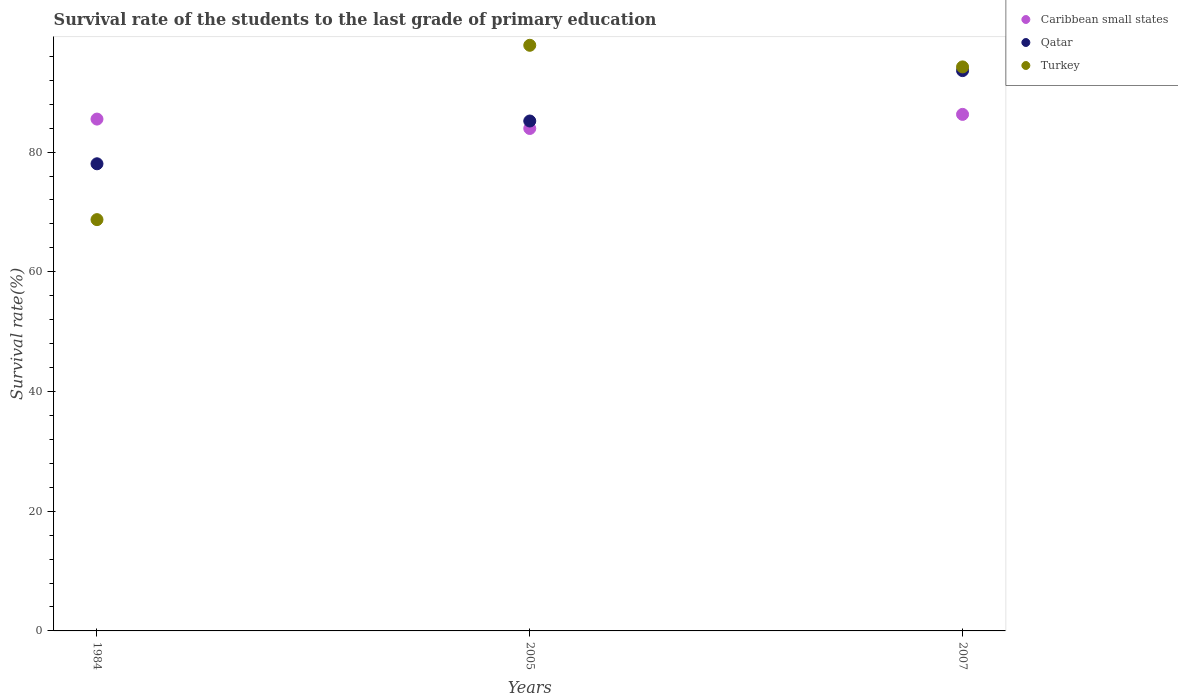Is the number of dotlines equal to the number of legend labels?
Provide a short and direct response. Yes. What is the survival rate of the students in Caribbean small states in 1984?
Your response must be concise. 85.51. Across all years, what is the maximum survival rate of the students in Caribbean small states?
Make the answer very short. 86.3. Across all years, what is the minimum survival rate of the students in Qatar?
Provide a short and direct response. 78.05. In which year was the survival rate of the students in Caribbean small states maximum?
Offer a very short reply. 2007. In which year was the survival rate of the students in Turkey minimum?
Offer a terse response. 1984. What is the total survival rate of the students in Turkey in the graph?
Offer a terse response. 260.79. What is the difference between the survival rate of the students in Caribbean small states in 1984 and that in 2007?
Offer a terse response. -0.79. What is the difference between the survival rate of the students in Turkey in 2005 and the survival rate of the students in Caribbean small states in 2007?
Provide a short and direct response. 11.54. What is the average survival rate of the students in Caribbean small states per year?
Give a very brief answer. 85.25. In the year 2007, what is the difference between the survival rate of the students in Caribbean small states and survival rate of the students in Turkey?
Provide a short and direct response. -7.93. In how many years, is the survival rate of the students in Caribbean small states greater than 36 %?
Your answer should be compact. 3. What is the ratio of the survival rate of the students in Caribbean small states in 1984 to that in 2007?
Your answer should be compact. 0.99. Is the survival rate of the students in Qatar in 2005 less than that in 2007?
Offer a terse response. Yes. What is the difference between the highest and the second highest survival rate of the students in Caribbean small states?
Provide a succinct answer. 0.79. What is the difference between the highest and the lowest survival rate of the students in Turkey?
Offer a terse response. 29.13. Is the sum of the survival rate of the students in Turkey in 1984 and 2005 greater than the maximum survival rate of the students in Qatar across all years?
Offer a terse response. Yes. Is it the case that in every year, the sum of the survival rate of the students in Qatar and survival rate of the students in Caribbean small states  is greater than the survival rate of the students in Turkey?
Give a very brief answer. Yes. Does the survival rate of the students in Caribbean small states monotonically increase over the years?
Provide a short and direct response. No. Is the survival rate of the students in Caribbean small states strictly greater than the survival rate of the students in Turkey over the years?
Offer a terse response. No. Is the survival rate of the students in Qatar strictly less than the survival rate of the students in Turkey over the years?
Your response must be concise. No. How many dotlines are there?
Keep it short and to the point. 3. What is the difference between two consecutive major ticks on the Y-axis?
Provide a succinct answer. 20. Are the values on the major ticks of Y-axis written in scientific E-notation?
Your answer should be compact. No. What is the title of the graph?
Give a very brief answer. Survival rate of the students to the last grade of primary education. What is the label or title of the X-axis?
Your answer should be compact. Years. What is the label or title of the Y-axis?
Provide a succinct answer. Survival rate(%). What is the Survival rate(%) of Caribbean small states in 1984?
Give a very brief answer. 85.51. What is the Survival rate(%) in Qatar in 1984?
Ensure brevity in your answer.  78.05. What is the Survival rate(%) of Turkey in 1984?
Make the answer very short. 68.72. What is the Survival rate(%) of Caribbean small states in 2005?
Ensure brevity in your answer.  83.94. What is the Survival rate(%) in Qatar in 2005?
Your response must be concise. 85.19. What is the Survival rate(%) of Turkey in 2005?
Your answer should be compact. 97.84. What is the Survival rate(%) of Caribbean small states in 2007?
Give a very brief answer. 86.3. What is the Survival rate(%) in Qatar in 2007?
Provide a short and direct response. 93.61. What is the Survival rate(%) of Turkey in 2007?
Provide a short and direct response. 94.23. Across all years, what is the maximum Survival rate(%) in Caribbean small states?
Your answer should be compact. 86.3. Across all years, what is the maximum Survival rate(%) in Qatar?
Make the answer very short. 93.61. Across all years, what is the maximum Survival rate(%) in Turkey?
Give a very brief answer. 97.84. Across all years, what is the minimum Survival rate(%) in Caribbean small states?
Provide a succinct answer. 83.94. Across all years, what is the minimum Survival rate(%) in Qatar?
Your answer should be very brief. 78.05. Across all years, what is the minimum Survival rate(%) in Turkey?
Make the answer very short. 68.72. What is the total Survival rate(%) of Caribbean small states in the graph?
Provide a short and direct response. 255.76. What is the total Survival rate(%) in Qatar in the graph?
Offer a terse response. 256.85. What is the total Survival rate(%) in Turkey in the graph?
Your response must be concise. 260.79. What is the difference between the Survival rate(%) in Caribbean small states in 1984 and that in 2005?
Your answer should be compact. 1.57. What is the difference between the Survival rate(%) in Qatar in 1984 and that in 2005?
Your answer should be very brief. -7.15. What is the difference between the Survival rate(%) of Turkey in 1984 and that in 2005?
Make the answer very short. -29.13. What is the difference between the Survival rate(%) in Caribbean small states in 1984 and that in 2007?
Keep it short and to the point. -0.79. What is the difference between the Survival rate(%) of Qatar in 1984 and that in 2007?
Provide a succinct answer. -15.57. What is the difference between the Survival rate(%) in Turkey in 1984 and that in 2007?
Give a very brief answer. -25.52. What is the difference between the Survival rate(%) of Caribbean small states in 2005 and that in 2007?
Your answer should be compact. -2.36. What is the difference between the Survival rate(%) in Qatar in 2005 and that in 2007?
Offer a very short reply. -8.42. What is the difference between the Survival rate(%) of Turkey in 2005 and that in 2007?
Give a very brief answer. 3.61. What is the difference between the Survival rate(%) in Caribbean small states in 1984 and the Survival rate(%) in Qatar in 2005?
Offer a terse response. 0.32. What is the difference between the Survival rate(%) in Caribbean small states in 1984 and the Survival rate(%) in Turkey in 2005?
Provide a succinct answer. -12.33. What is the difference between the Survival rate(%) in Qatar in 1984 and the Survival rate(%) in Turkey in 2005?
Keep it short and to the point. -19.8. What is the difference between the Survival rate(%) in Caribbean small states in 1984 and the Survival rate(%) in Qatar in 2007?
Make the answer very short. -8.1. What is the difference between the Survival rate(%) of Caribbean small states in 1984 and the Survival rate(%) of Turkey in 2007?
Give a very brief answer. -8.72. What is the difference between the Survival rate(%) in Qatar in 1984 and the Survival rate(%) in Turkey in 2007?
Your response must be concise. -16.19. What is the difference between the Survival rate(%) of Caribbean small states in 2005 and the Survival rate(%) of Qatar in 2007?
Ensure brevity in your answer.  -9.67. What is the difference between the Survival rate(%) of Caribbean small states in 2005 and the Survival rate(%) of Turkey in 2007?
Ensure brevity in your answer.  -10.29. What is the difference between the Survival rate(%) of Qatar in 2005 and the Survival rate(%) of Turkey in 2007?
Make the answer very short. -9.04. What is the average Survival rate(%) of Caribbean small states per year?
Your answer should be very brief. 85.25. What is the average Survival rate(%) in Qatar per year?
Offer a terse response. 85.62. What is the average Survival rate(%) in Turkey per year?
Your answer should be very brief. 86.93. In the year 1984, what is the difference between the Survival rate(%) of Caribbean small states and Survival rate(%) of Qatar?
Your answer should be compact. 7.47. In the year 1984, what is the difference between the Survival rate(%) of Caribbean small states and Survival rate(%) of Turkey?
Your response must be concise. 16.8. In the year 1984, what is the difference between the Survival rate(%) of Qatar and Survival rate(%) of Turkey?
Make the answer very short. 9.33. In the year 2005, what is the difference between the Survival rate(%) of Caribbean small states and Survival rate(%) of Qatar?
Your response must be concise. -1.25. In the year 2005, what is the difference between the Survival rate(%) in Caribbean small states and Survival rate(%) in Turkey?
Your answer should be compact. -13.9. In the year 2005, what is the difference between the Survival rate(%) in Qatar and Survival rate(%) in Turkey?
Provide a succinct answer. -12.65. In the year 2007, what is the difference between the Survival rate(%) of Caribbean small states and Survival rate(%) of Qatar?
Make the answer very short. -7.31. In the year 2007, what is the difference between the Survival rate(%) of Caribbean small states and Survival rate(%) of Turkey?
Your answer should be very brief. -7.93. In the year 2007, what is the difference between the Survival rate(%) of Qatar and Survival rate(%) of Turkey?
Your answer should be compact. -0.62. What is the ratio of the Survival rate(%) in Caribbean small states in 1984 to that in 2005?
Offer a very short reply. 1.02. What is the ratio of the Survival rate(%) of Qatar in 1984 to that in 2005?
Make the answer very short. 0.92. What is the ratio of the Survival rate(%) in Turkey in 1984 to that in 2005?
Provide a succinct answer. 0.7. What is the ratio of the Survival rate(%) of Caribbean small states in 1984 to that in 2007?
Make the answer very short. 0.99. What is the ratio of the Survival rate(%) of Qatar in 1984 to that in 2007?
Give a very brief answer. 0.83. What is the ratio of the Survival rate(%) of Turkey in 1984 to that in 2007?
Give a very brief answer. 0.73. What is the ratio of the Survival rate(%) of Caribbean small states in 2005 to that in 2007?
Offer a very short reply. 0.97. What is the ratio of the Survival rate(%) in Qatar in 2005 to that in 2007?
Offer a terse response. 0.91. What is the ratio of the Survival rate(%) in Turkey in 2005 to that in 2007?
Ensure brevity in your answer.  1.04. What is the difference between the highest and the second highest Survival rate(%) of Caribbean small states?
Keep it short and to the point. 0.79. What is the difference between the highest and the second highest Survival rate(%) of Qatar?
Offer a very short reply. 8.42. What is the difference between the highest and the second highest Survival rate(%) of Turkey?
Make the answer very short. 3.61. What is the difference between the highest and the lowest Survival rate(%) of Caribbean small states?
Give a very brief answer. 2.36. What is the difference between the highest and the lowest Survival rate(%) in Qatar?
Offer a very short reply. 15.57. What is the difference between the highest and the lowest Survival rate(%) of Turkey?
Your answer should be compact. 29.13. 